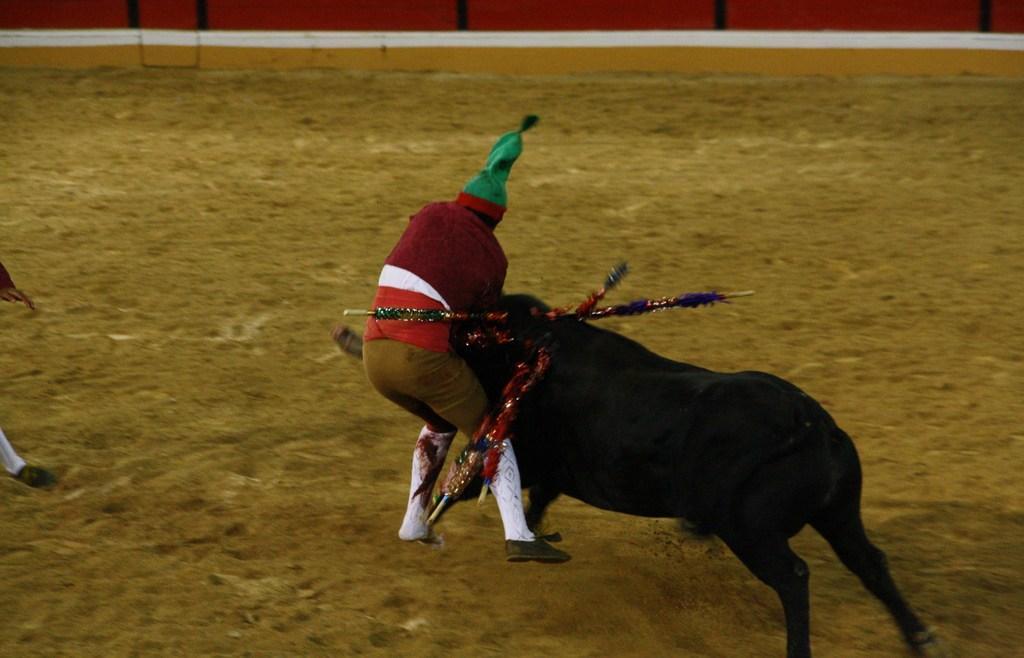Describe this image in one or two sentences. In the image we can see a person wearing clothes, cap, socks and shoes. This is an animal, black in color. This is a sand and these are the sticks, there is another person wearing shoes. 